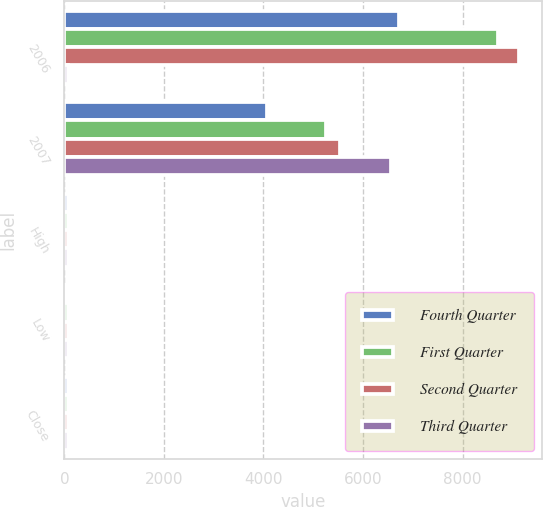Convert chart. <chart><loc_0><loc_0><loc_500><loc_500><stacked_bar_chart><ecel><fcel>2006<fcel>2007<fcel>High<fcel>Low<fcel>Close<nl><fcel>Fourth Quarter<fcel>6719<fcel>4065<fcel>65.54<fcel>61.89<fcel>64.09<nl><fcel>First Quarter<fcel>8714<fcel>5265<fcel>69.64<fcel>62.57<fcel>66.68<nl><fcel>Second Quarter<fcel>9134<fcel>5544<fcel>70.25<fcel>64.25<fcel>67.98<nl><fcel>Third Quarter<fcel>70.25<fcel>6562<fcel>79<fcel>68.02<fcel>77.03<nl></chart> 